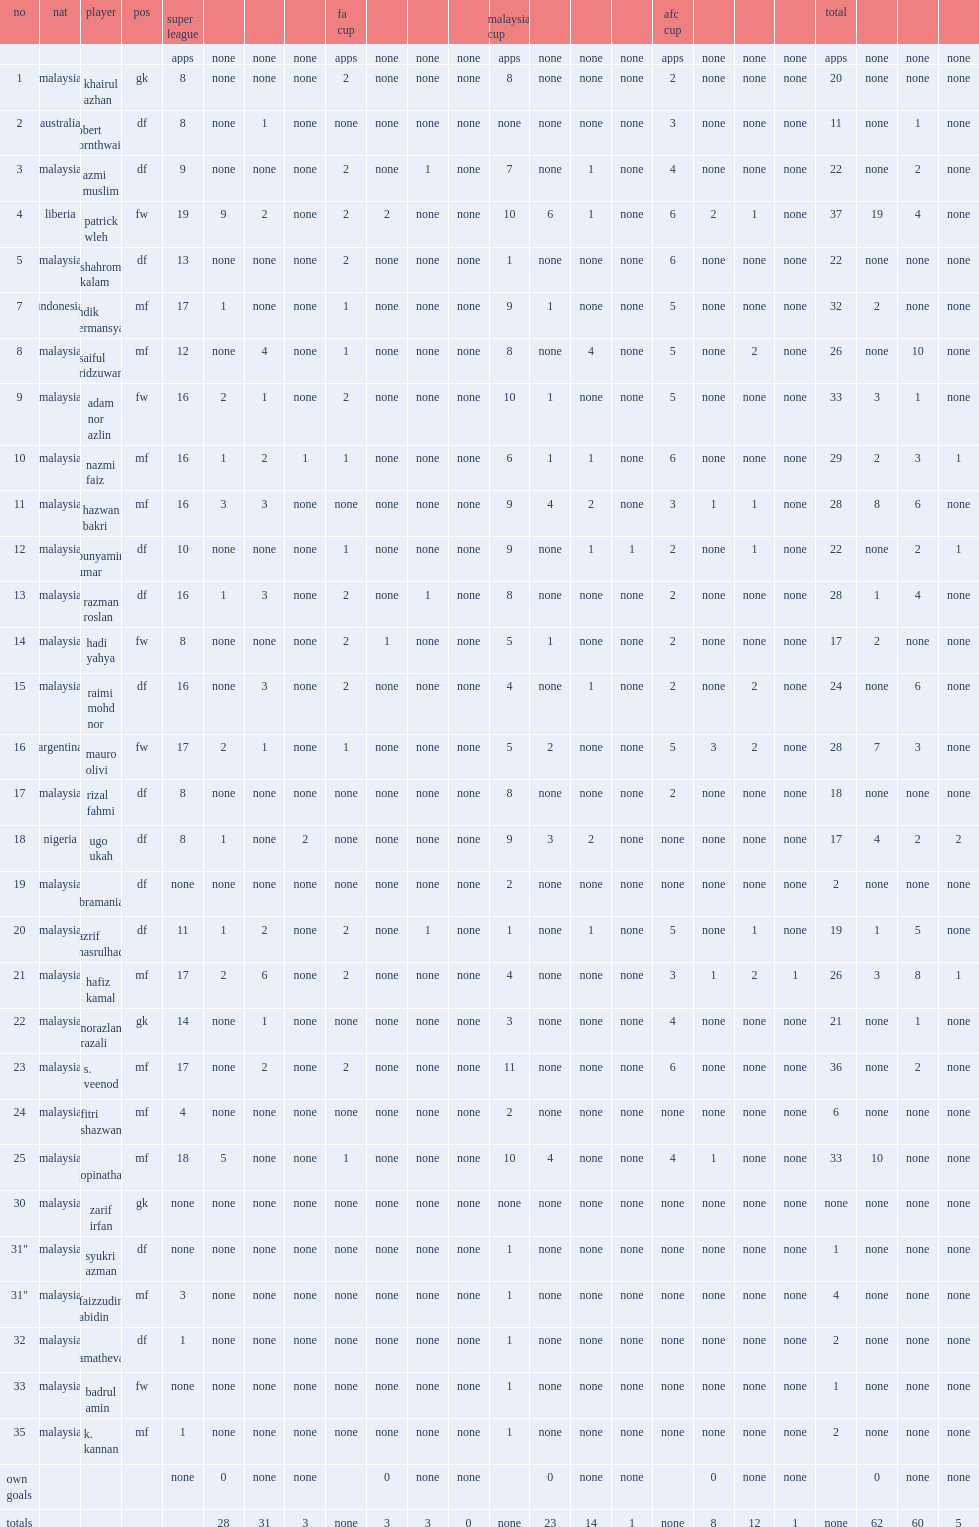List the matches that selangor competed in. Fa cup malaysia cup. 